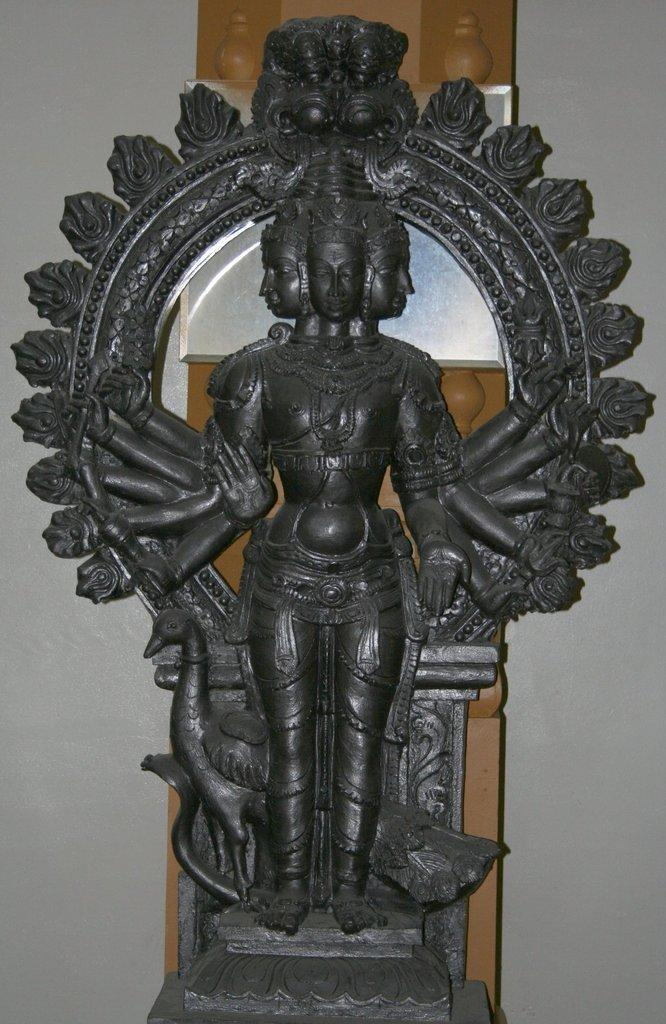What is the main subject in the image? There is a statue in the image. What can be seen in the background of the image? There are objects visible in the background of the image. What type of architectural feature is present in the background of the image? There is a wall in the background of the image. What type of blade is being used by the woman in the image? There is no woman or blade present in the image; it features a statue and objects in the background. 